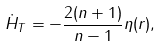Convert formula to latex. <formula><loc_0><loc_0><loc_500><loc_500>\dot { H } _ { T } = - \frac { 2 ( n + 1 ) } { n - 1 } \eta ( r ) ,</formula> 